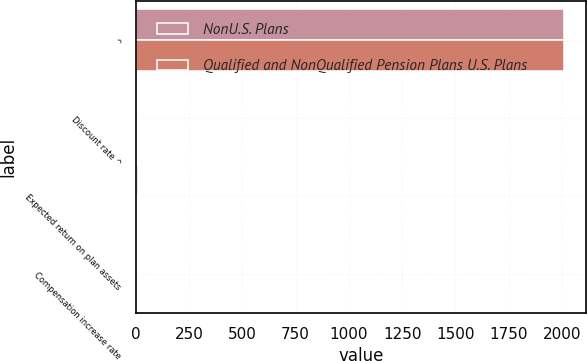Convert chart. <chart><loc_0><loc_0><loc_500><loc_500><stacked_bar_chart><ecel><fcel>^<fcel>Discount rate ^<fcel>Expected return on plan assets<fcel>Compensation increase rate<nl><fcel>NonU.S. Plans<fcel>2011<fcel>5.42<fcel>8<fcel>4<nl><fcel>Qualified and NonQualified Pension Plans U.S. Plans<fcel>2011<fcel>5.8<fcel>7<fcel>4.5<nl></chart> 